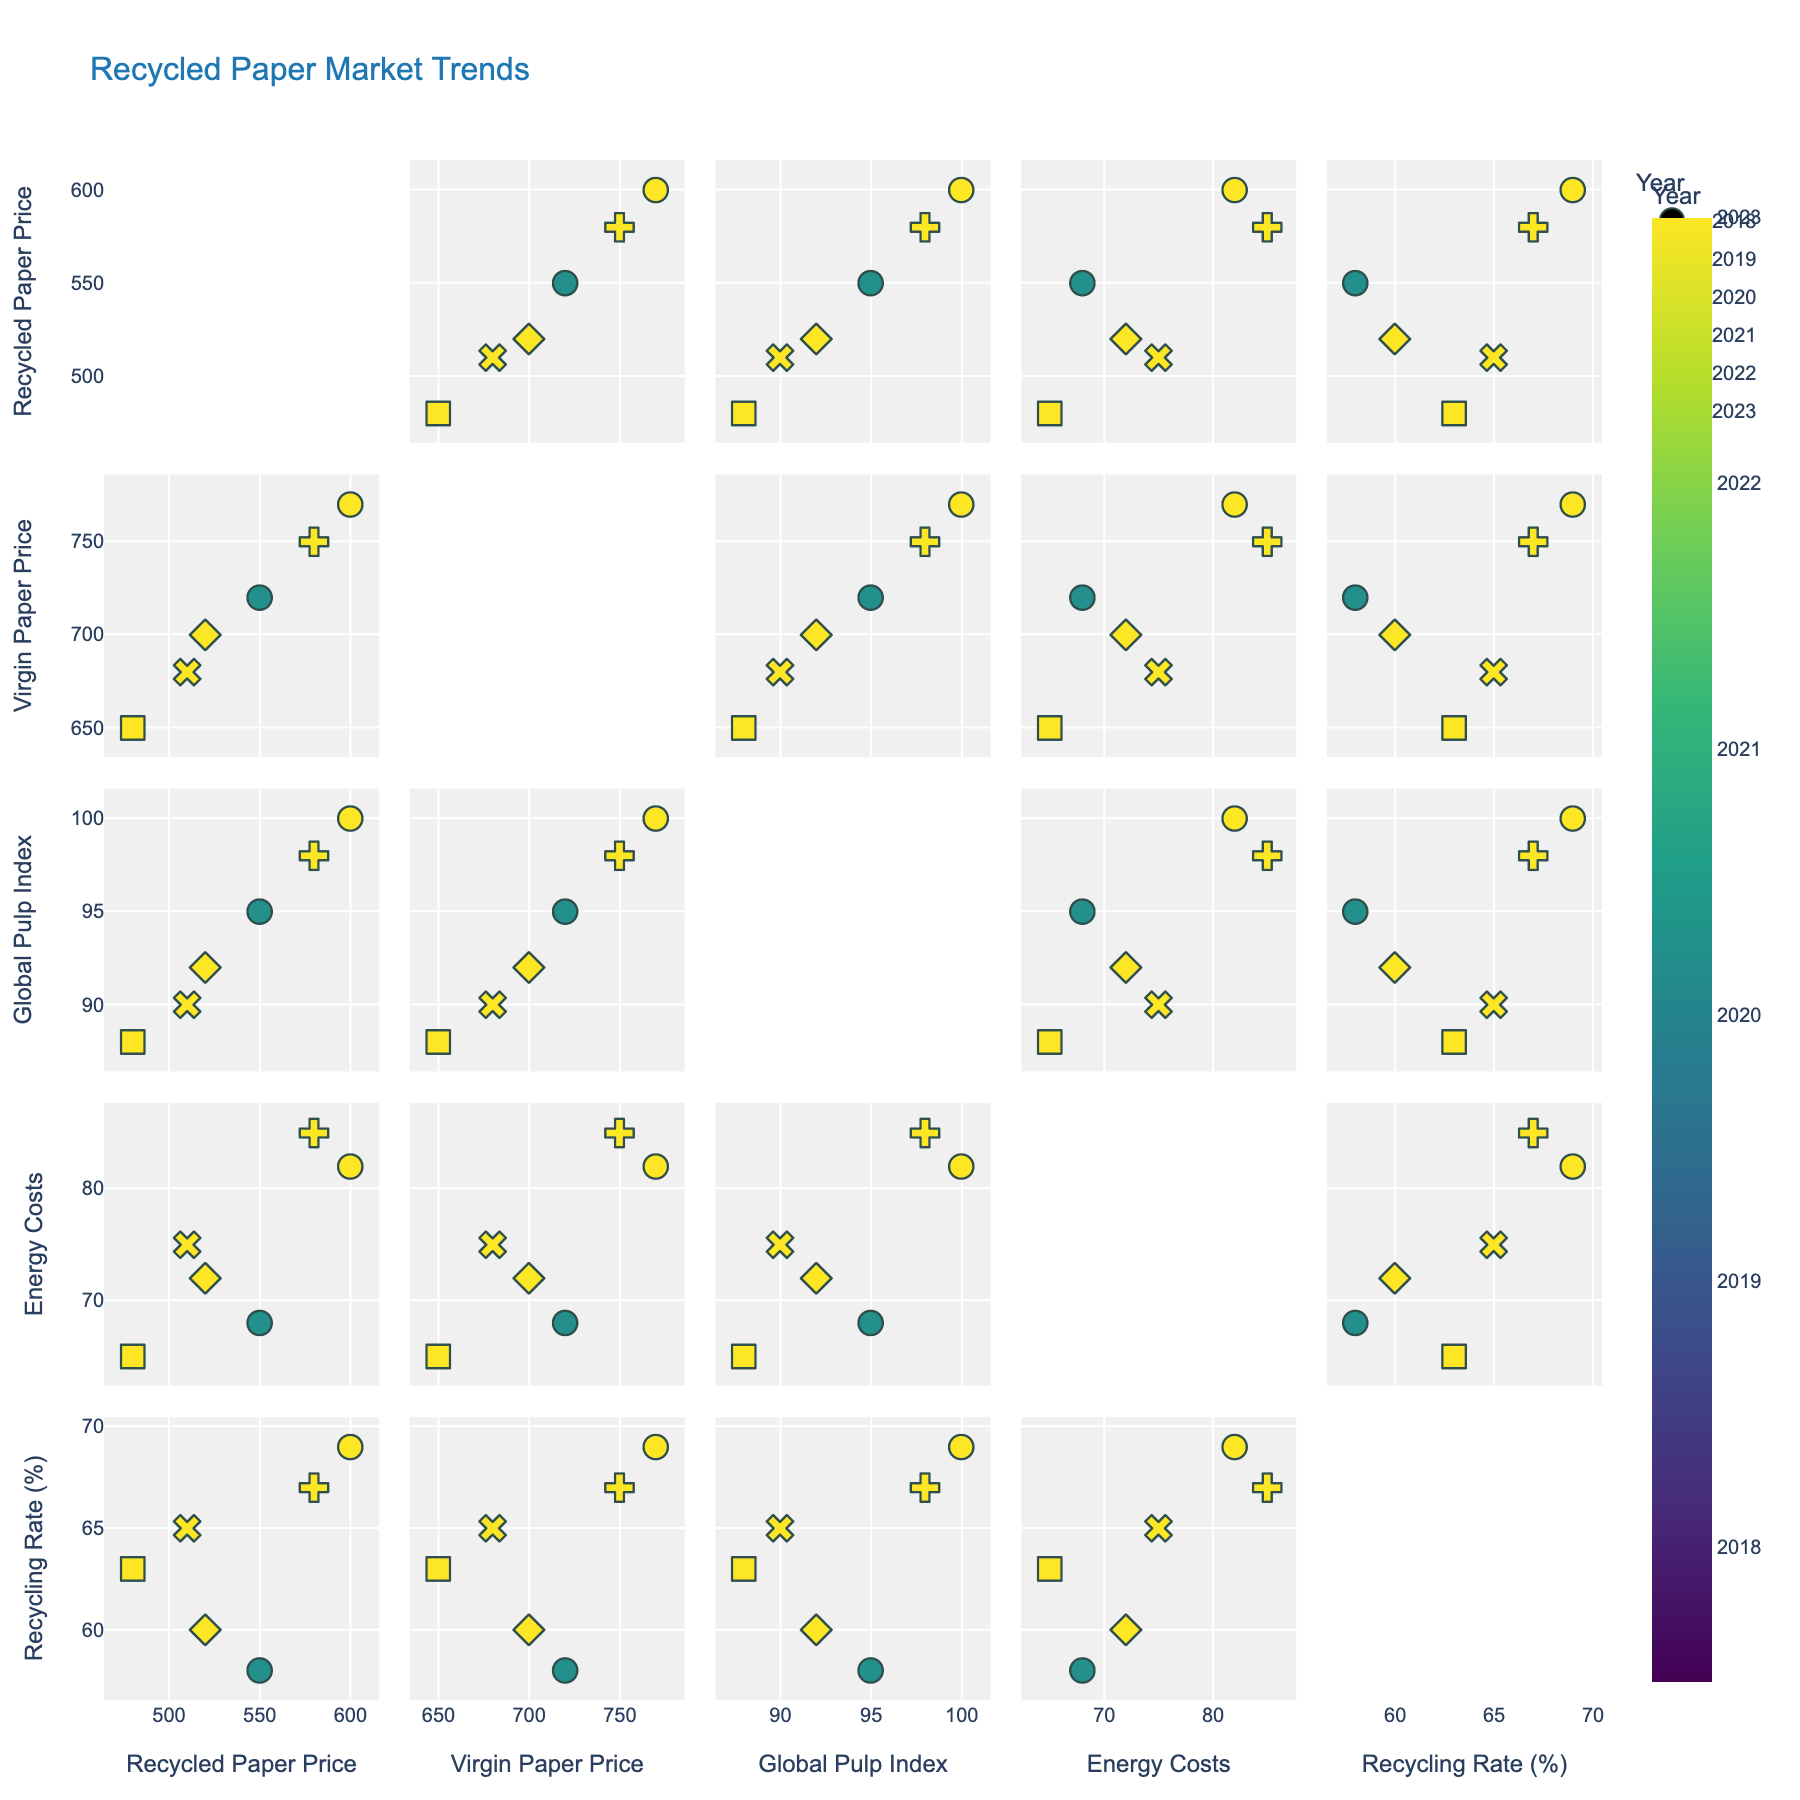What is the title of the scatterplot matrix? The title of a plot is typically displayed at the top. In this case, it is "Recycled Paper Market Trends" as defined in the code.
Answer: Recycled Paper Market Trends How many dimensions are plotted in the scatterplot matrix? The scatterplot matrix includes five variables: Recycled Paper Price, Virgin Paper Price, Global Pulp Index, Energy Costs, and Recycling Rate.
Answer: Five Which year has the highest Recycled Paper Price? By looking at the scatter points colored and symbolized by year, the year 2023 has the highest value for Recycled Paper Price.
Answer: 2023 Is there an overall trend in the Virgin Paper Price over the years? Examining sequential points for Virgin Paper Price, it generally shows an increasing trend from 2018 to 2023.
Answer: Increasing Do higher Energy Costs correlate with higher Recycled Paper Prices? By observing the scatter points between Energy Costs and Recycled Paper Price, there is a positive correlation where higher Energy Costs are associated with higher Recycled Paper Prices.
Answer: Yes Which year exhibits the lowest Global Pulp Index? Look for the lowest point in the Global Pulp Index dimension. The year with the lowest value is 2020.
Answer: 2020 Is there a noticeable relationship between Recycling Rate and Energy Costs? By observing the scatter points between Recycling Rate and Energy Costs, there does not appear to be any clear relationship.
Answer: No Does the Recycled Paper Price increase or decrease as the Global Pulp Index increases? By looking at the scatter points between Recycled Paper Price and Global Pulp Index, there is a generally increasing trend.
Answer: Increases For which two dimensions is the correlation most evident? Through visual inspection, the most evident correlation appears to be between Recycled Paper Price and Energy Costs. The points form a clear upward trend.
Answer: Recycled Paper Price and Energy Costs 